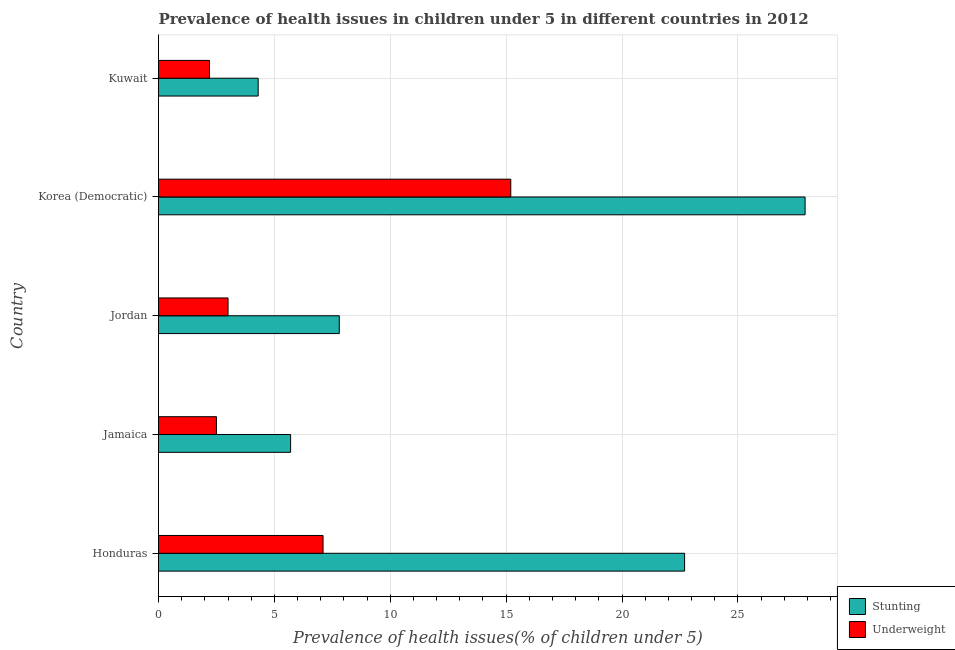How many bars are there on the 3rd tick from the top?
Your answer should be compact. 2. How many bars are there on the 5th tick from the bottom?
Your answer should be compact. 2. What is the label of the 4th group of bars from the top?
Your response must be concise. Jamaica. What is the percentage of stunted children in Kuwait?
Make the answer very short. 4.3. Across all countries, what is the maximum percentage of stunted children?
Give a very brief answer. 27.9. Across all countries, what is the minimum percentage of underweight children?
Make the answer very short. 2.2. In which country was the percentage of underweight children maximum?
Your answer should be compact. Korea (Democratic). In which country was the percentage of stunted children minimum?
Offer a very short reply. Kuwait. What is the total percentage of stunted children in the graph?
Ensure brevity in your answer.  68.4. What is the difference between the percentage of stunted children in Honduras and the percentage of underweight children in Jamaica?
Your answer should be compact. 20.2. What is the average percentage of stunted children per country?
Make the answer very short. 13.68. What is the difference between the percentage of stunted children and percentage of underweight children in Korea (Democratic)?
Your answer should be compact. 12.7. What is the ratio of the percentage of underweight children in Honduras to that in Kuwait?
Offer a very short reply. 3.23. Is the percentage of stunted children in Jamaica less than that in Jordan?
Your response must be concise. Yes. Is the difference between the percentage of stunted children in Jamaica and Kuwait greater than the difference between the percentage of underweight children in Jamaica and Kuwait?
Provide a succinct answer. Yes. Is the sum of the percentage of underweight children in Honduras and Jamaica greater than the maximum percentage of stunted children across all countries?
Your answer should be compact. No. What does the 2nd bar from the top in Jordan represents?
Your response must be concise. Stunting. What does the 1st bar from the bottom in Korea (Democratic) represents?
Provide a succinct answer. Stunting. What is the difference between two consecutive major ticks on the X-axis?
Keep it short and to the point. 5. Are the values on the major ticks of X-axis written in scientific E-notation?
Your answer should be compact. No. Does the graph contain any zero values?
Your answer should be very brief. No. Does the graph contain grids?
Provide a succinct answer. Yes. How many legend labels are there?
Provide a short and direct response. 2. What is the title of the graph?
Provide a short and direct response. Prevalence of health issues in children under 5 in different countries in 2012. What is the label or title of the X-axis?
Keep it short and to the point. Prevalence of health issues(% of children under 5). What is the Prevalence of health issues(% of children under 5) of Stunting in Honduras?
Keep it short and to the point. 22.7. What is the Prevalence of health issues(% of children under 5) in Underweight in Honduras?
Give a very brief answer. 7.1. What is the Prevalence of health issues(% of children under 5) in Stunting in Jamaica?
Provide a short and direct response. 5.7. What is the Prevalence of health issues(% of children under 5) of Underweight in Jamaica?
Your answer should be very brief. 2.5. What is the Prevalence of health issues(% of children under 5) in Stunting in Jordan?
Offer a very short reply. 7.8. What is the Prevalence of health issues(% of children under 5) of Underweight in Jordan?
Your response must be concise. 3. What is the Prevalence of health issues(% of children under 5) in Stunting in Korea (Democratic)?
Keep it short and to the point. 27.9. What is the Prevalence of health issues(% of children under 5) of Underweight in Korea (Democratic)?
Offer a very short reply. 15.2. What is the Prevalence of health issues(% of children under 5) of Stunting in Kuwait?
Offer a very short reply. 4.3. What is the Prevalence of health issues(% of children under 5) of Underweight in Kuwait?
Offer a very short reply. 2.2. Across all countries, what is the maximum Prevalence of health issues(% of children under 5) of Stunting?
Provide a succinct answer. 27.9. Across all countries, what is the maximum Prevalence of health issues(% of children under 5) of Underweight?
Ensure brevity in your answer.  15.2. Across all countries, what is the minimum Prevalence of health issues(% of children under 5) in Stunting?
Give a very brief answer. 4.3. Across all countries, what is the minimum Prevalence of health issues(% of children under 5) of Underweight?
Ensure brevity in your answer.  2.2. What is the total Prevalence of health issues(% of children under 5) in Stunting in the graph?
Provide a short and direct response. 68.4. What is the total Prevalence of health issues(% of children under 5) of Underweight in the graph?
Offer a terse response. 30. What is the difference between the Prevalence of health issues(% of children under 5) in Underweight in Honduras and that in Jamaica?
Ensure brevity in your answer.  4.6. What is the difference between the Prevalence of health issues(% of children under 5) in Underweight in Honduras and that in Jordan?
Give a very brief answer. 4.1. What is the difference between the Prevalence of health issues(% of children under 5) of Underweight in Honduras and that in Korea (Democratic)?
Make the answer very short. -8.1. What is the difference between the Prevalence of health issues(% of children under 5) of Underweight in Honduras and that in Kuwait?
Your response must be concise. 4.9. What is the difference between the Prevalence of health issues(% of children under 5) of Stunting in Jamaica and that in Jordan?
Your answer should be compact. -2.1. What is the difference between the Prevalence of health issues(% of children under 5) of Underweight in Jamaica and that in Jordan?
Your answer should be compact. -0.5. What is the difference between the Prevalence of health issues(% of children under 5) in Stunting in Jamaica and that in Korea (Democratic)?
Offer a very short reply. -22.2. What is the difference between the Prevalence of health issues(% of children under 5) of Stunting in Jamaica and that in Kuwait?
Ensure brevity in your answer.  1.4. What is the difference between the Prevalence of health issues(% of children under 5) of Stunting in Jordan and that in Korea (Democratic)?
Offer a terse response. -20.1. What is the difference between the Prevalence of health issues(% of children under 5) of Underweight in Jordan and that in Korea (Democratic)?
Your answer should be compact. -12.2. What is the difference between the Prevalence of health issues(% of children under 5) of Stunting in Jordan and that in Kuwait?
Your answer should be compact. 3.5. What is the difference between the Prevalence of health issues(% of children under 5) of Underweight in Jordan and that in Kuwait?
Keep it short and to the point. 0.8. What is the difference between the Prevalence of health issues(% of children under 5) of Stunting in Korea (Democratic) and that in Kuwait?
Provide a short and direct response. 23.6. What is the difference between the Prevalence of health issues(% of children under 5) in Stunting in Honduras and the Prevalence of health issues(% of children under 5) in Underweight in Jamaica?
Provide a succinct answer. 20.2. What is the difference between the Prevalence of health issues(% of children under 5) in Stunting in Honduras and the Prevalence of health issues(% of children under 5) in Underweight in Kuwait?
Provide a succinct answer. 20.5. What is the difference between the Prevalence of health issues(% of children under 5) in Stunting in Jamaica and the Prevalence of health issues(% of children under 5) in Underweight in Jordan?
Give a very brief answer. 2.7. What is the difference between the Prevalence of health issues(% of children under 5) of Stunting in Jordan and the Prevalence of health issues(% of children under 5) of Underweight in Kuwait?
Make the answer very short. 5.6. What is the difference between the Prevalence of health issues(% of children under 5) of Stunting in Korea (Democratic) and the Prevalence of health issues(% of children under 5) of Underweight in Kuwait?
Your answer should be compact. 25.7. What is the average Prevalence of health issues(% of children under 5) of Stunting per country?
Make the answer very short. 13.68. What is the average Prevalence of health issues(% of children under 5) of Underweight per country?
Your response must be concise. 6. What is the difference between the Prevalence of health issues(% of children under 5) of Stunting and Prevalence of health issues(% of children under 5) of Underweight in Korea (Democratic)?
Keep it short and to the point. 12.7. What is the ratio of the Prevalence of health issues(% of children under 5) of Stunting in Honduras to that in Jamaica?
Provide a short and direct response. 3.98. What is the ratio of the Prevalence of health issues(% of children under 5) of Underweight in Honduras to that in Jamaica?
Make the answer very short. 2.84. What is the ratio of the Prevalence of health issues(% of children under 5) of Stunting in Honduras to that in Jordan?
Your response must be concise. 2.91. What is the ratio of the Prevalence of health issues(% of children under 5) in Underweight in Honduras to that in Jordan?
Provide a succinct answer. 2.37. What is the ratio of the Prevalence of health issues(% of children under 5) of Stunting in Honduras to that in Korea (Democratic)?
Provide a short and direct response. 0.81. What is the ratio of the Prevalence of health issues(% of children under 5) in Underweight in Honduras to that in Korea (Democratic)?
Provide a succinct answer. 0.47. What is the ratio of the Prevalence of health issues(% of children under 5) in Stunting in Honduras to that in Kuwait?
Provide a short and direct response. 5.28. What is the ratio of the Prevalence of health issues(% of children under 5) in Underweight in Honduras to that in Kuwait?
Provide a short and direct response. 3.23. What is the ratio of the Prevalence of health issues(% of children under 5) in Stunting in Jamaica to that in Jordan?
Provide a short and direct response. 0.73. What is the ratio of the Prevalence of health issues(% of children under 5) in Stunting in Jamaica to that in Korea (Democratic)?
Offer a terse response. 0.2. What is the ratio of the Prevalence of health issues(% of children under 5) of Underweight in Jamaica to that in Korea (Democratic)?
Offer a very short reply. 0.16. What is the ratio of the Prevalence of health issues(% of children under 5) of Stunting in Jamaica to that in Kuwait?
Provide a short and direct response. 1.33. What is the ratio of the Prevalence of health issues(% of children under 5) in Underweight in Jamaica to that in Kuwait?
Make the answer very short. 1.14. What is the ratio of the Prevalence of health issues(% of children under 5) in Stunting in Jordan to that in Korea (Democratic)?
Offer a very short reply. 0.28. What is the ratio of the Prevalence of health issues(% of children under 5) of Underweight in Jordan to that in Korea (Democratic)?
Keep it short and to the point. 0.2. What is the ratio of the Prevalence of health issues(% of children under 5) in Stunting in Jordan to that in Kuwait?
Provide a succinct answer. 1.81. What is the ratio of the Prevalence of health issues(% of children under 5) of Underweight in Jordan to that in Kuwait?
Provide a succinct answer. 1.36. What is the ratio of the Prevalence of health issues(% of children under 5) of Stunting in Korea (Democratic) to that in Kuwait?
Offer a very short reply. 6.49. What is the ratio of the Prevalence of health issues(% of children under 5) in Underweight in Korea (Democratic) to that in Kuwait?
Ensure brevity in your answer.  6.91. What is the difference between the highest and the lowest Prevalence of health issues(% of children under 5) of Stunting?
Provide a succinct answer. 23.6. What is the difference between the highest and the lowest Prevalence of health issues(% of children under 5) of Underweight?
Provide a succinct answer. 13. 